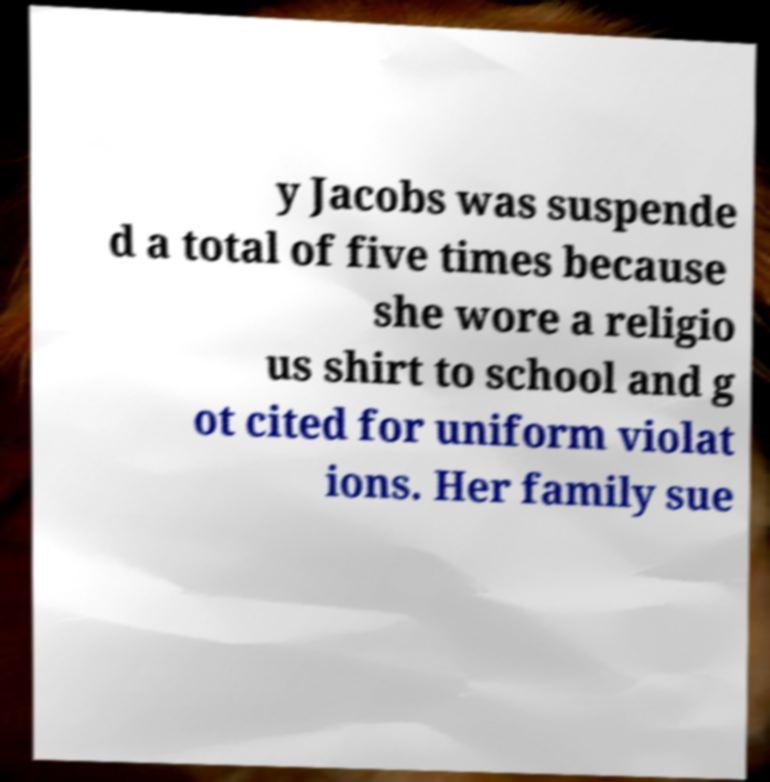What messages or text are displayed in this image? I need them in a readable, typed format. y Jacobs was suspende d a total of five times because she wore a religio us shirt to school and g ot cited for uniform violat ions. Her family sue 